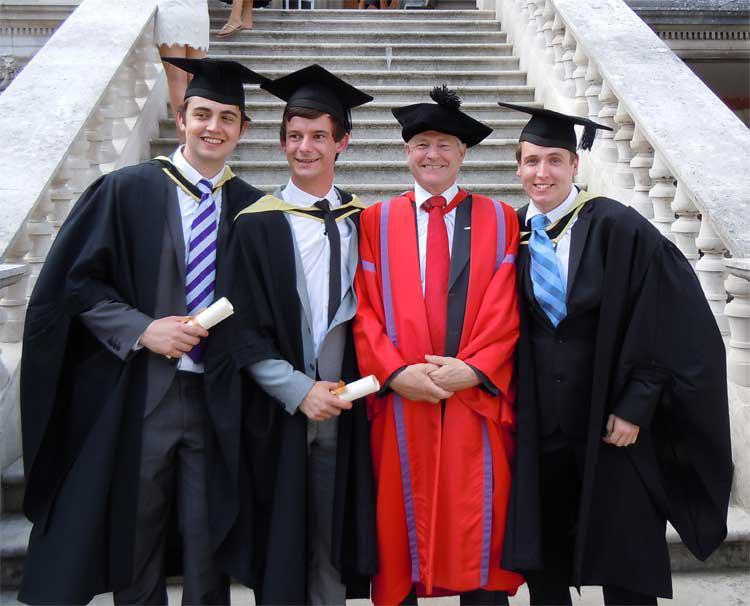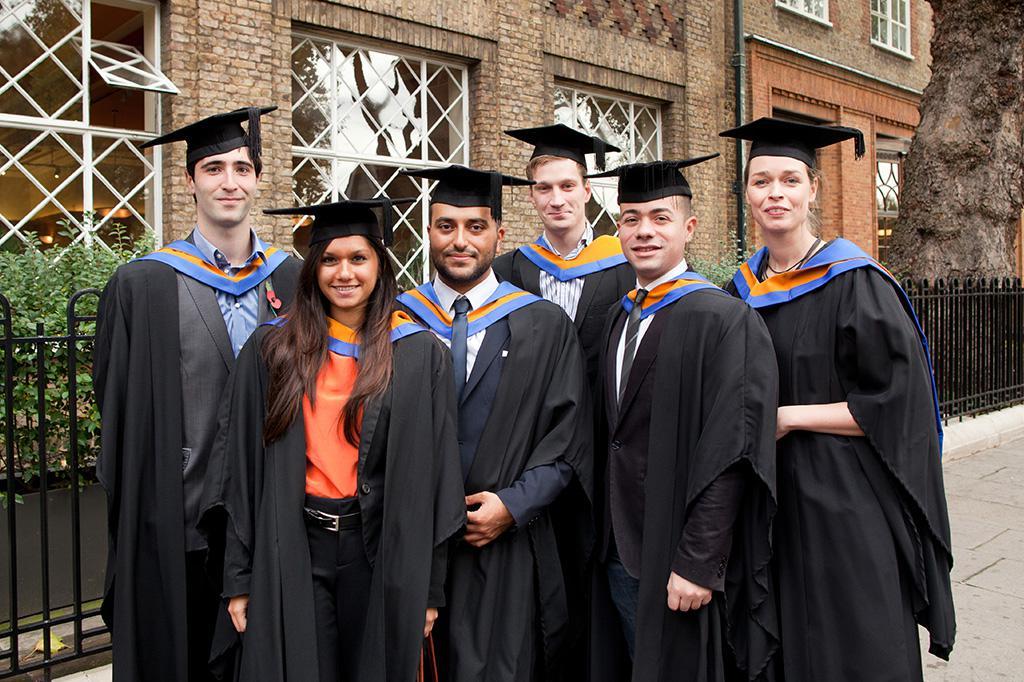The first image is the image on the left, the second image is the image on the right. Given the left and right images, does the statement "There are four graduates in one of the images." hold true? Answer yes or no. Yes. The first image is the image on the left, the second image is the image on the right. For the images displayed, is the sentence "One image shows a single row of standing, camera-facing graduates numbering no more than four, and the other image includes at least some standing graduates who are not facing forward." factually correct? Answer yes or no. No. 